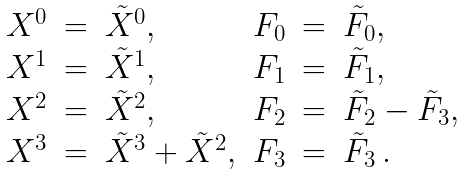Convert formula to latex. <formula><loc_0><loc_0><loc_500><loc_500>\begin{array} { r c l r c l } X ^ { 0 } & = & \tilde { X } ^ { 0 } , & F _ { 0 } & = & \tilde { F } _ { 0 } , \\ X ^ { 1 } & = & \tilde { X } ^ { 1 } , & F _ { 1 } & = & \tilde { F } _ { 1 } , \\ X ^ { 2 } & = & \tilde { X } ^ { 2 } , & F _ { 2 } & = & \tilde { F } _ { 2 } - \tilde { F } _ { 3 } , \\ X ^ { 3 } & = & \tilde { X } ^ { 3 } + \tilde { X } ^ { 2 } , & F _ { 3 } & = & \tilde { F } _ { 3 } \ . \end{array}</formula> 